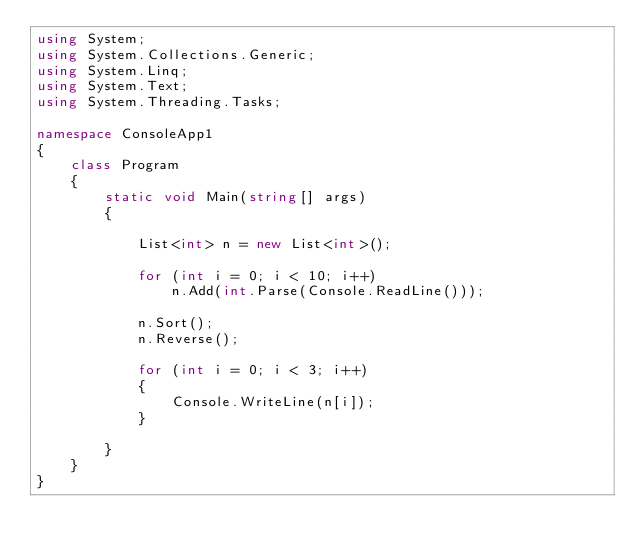Convert code to text. <code><loc_0><loc_0><loc_500><loc_500><_C#_>using System;
using System.Collections.Generic;
using System.Linq;
using System.Text;
using System.Threading.Tasks;

namespace ConsoleApp1
{
    class Program
    {
        static void Main(string[] args)
        {

            List<int> n = new List<int>();

            for (int i = 0; i < 10; i++)
                n.Add(int.Parse(Console.ReadLine()));

            n.Sort();
            n.Reverse();

            for (int i = 0; i < 3; i++)
            {
                Console.WriteLine(n[i]);
            }

        }
    }
}</code> 